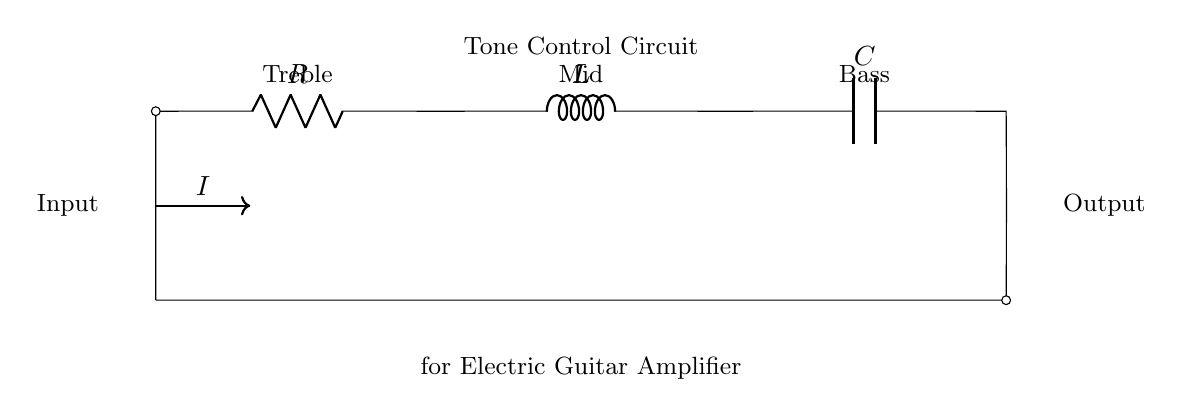What are the components shown in the circuit? The components in this series RLC circuit are a resistor (R), an inductor (L), and a capacitor (C). These elements are connected sequentially to form the circuit.
Answer: Resistor, Inductor, Capacitor What does the arrow in the diagram represent? The arrow in the diagram indicates the direction of current flow (I) in the circuit. This shows how the electrical current moves through the components from the input to the output.
Answer: Current flow What is the purpose of the tone control circuit? The tone control circuit modifies the tonal quality of the audio signal passing through it, allowing adjustments for treble, mid, and bass frequencies. Each component plays a role in shaping these frequencies.
Answer: Tone modification How many outputs are indicated in the circuit? The circuit diagram shows one output leading to the right, which is where the audio signal exits after being processed by the RLC components.
Answer: One output What arrangement do the components follow in this RLC circuit? The components are arranged in series, meaning that the current flows through each component one after the other. This series arrangement affects the overall impedance and tonal balance of the circuit.
Answer: Series arrangement What frequency bands can be adjusted in this circuit? The frequency bands that can be adjusted are treble, mid, and bass. These adjustments are typically handled by altering the values or presence of R, L, or C in the circuit, thereby changing their impact on the audio signal.
Answer: Treble, Mid, Bass Why is this RLC circuit relevant for electric guitar amplifiers? RLC circuits are used in electric guitar amplifiers to tailor the sound of the instrument, allowing musicians to achieve desired tonal qualities and improve their overall sound. This is essential for players who want to maintain their unique artistic expression.
Answer: Sound tailoring 